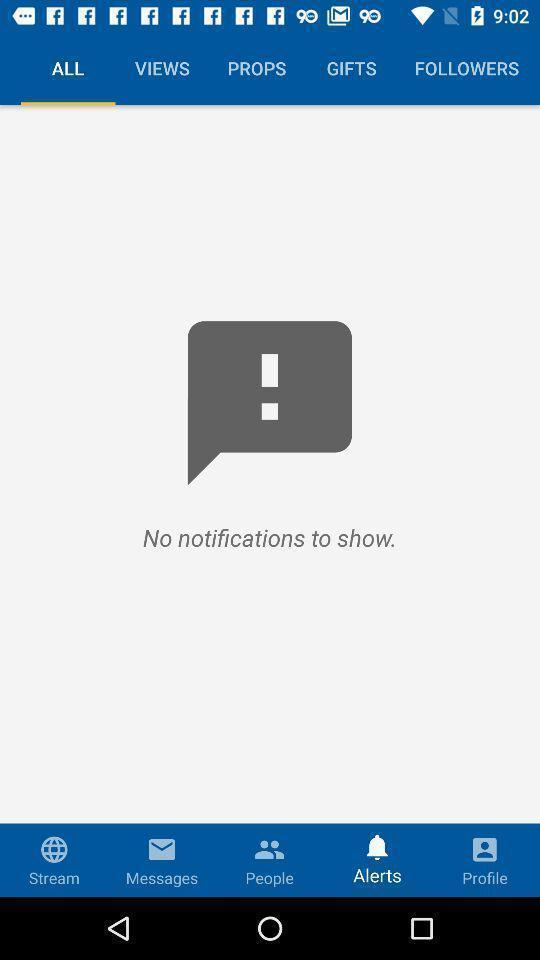What details can you identify in this image? Screen page displaying various options in social application. 